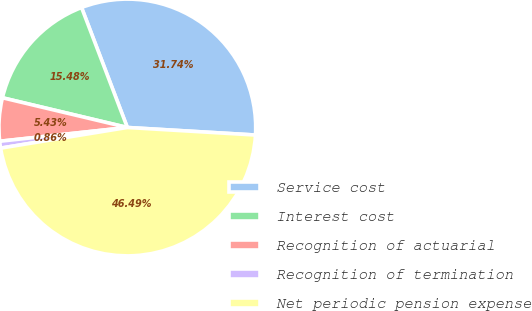Convert chart. <chart><loc_0><loc_0><loc_500><loc_500><pie_chart><fcel>Service cost<fcel>Interest cost<fcel>Recognition of actuarial<fcel>Recognition of termination<fcel>Net periodic pension expense<nl><fcel>31.74%<fcel>15.48%<fcel>5.43%<fcel>0.86%<fcel>46.49%<nl></chart> 